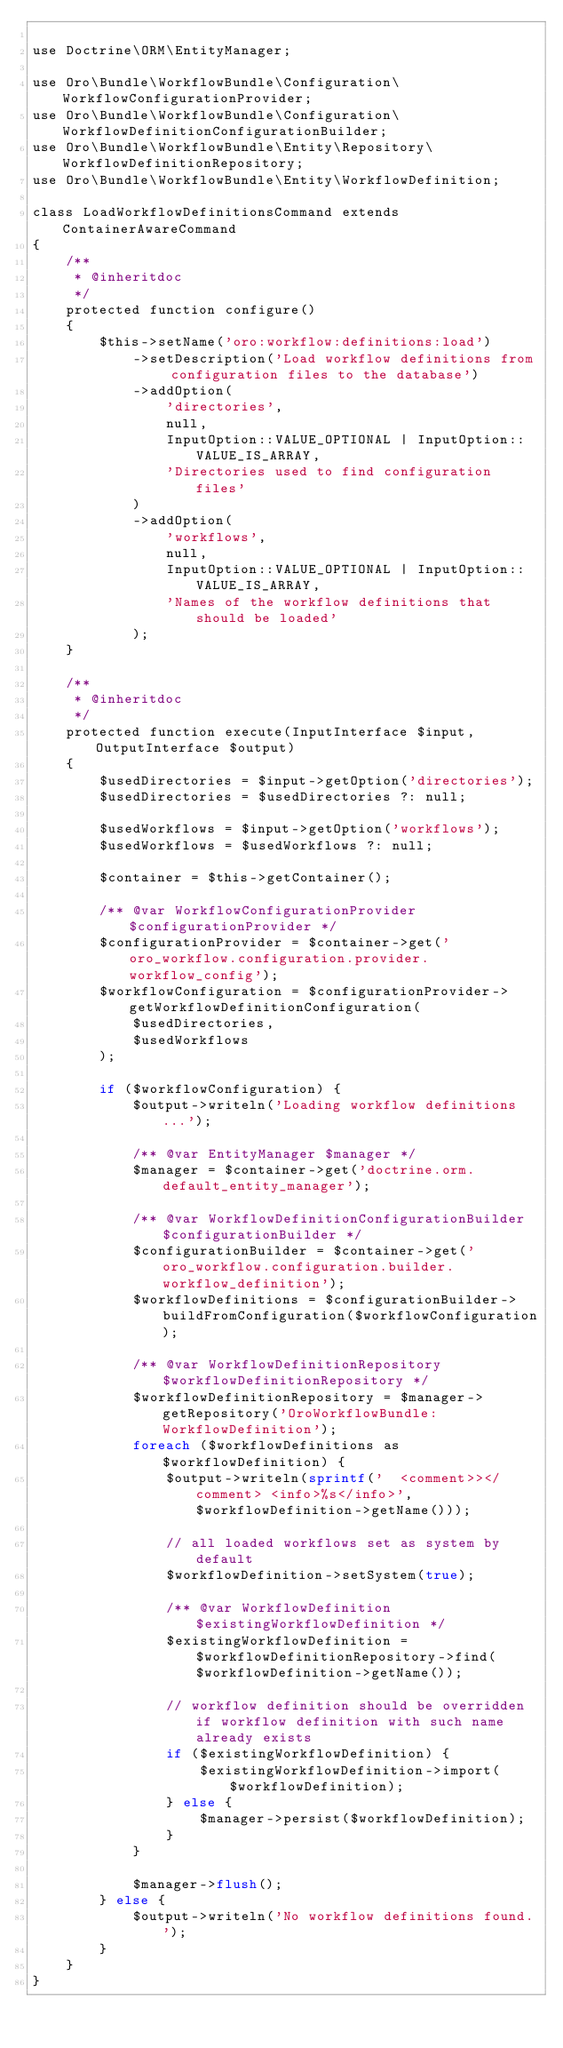Convert code to text. <code><loc_0><loc_0><loc_500><loc_500><_PHP_>
use Doctrine\ORM\EntityManager;

use Oro\Bundle\WorkflowBundle\Configuration\WorkflowConfigurationProvider;
use Oro\Bundle\WorkflowBundle\Configuration\WorkflowDefinitionConfigurationBuilder;
use Oro\Bundle\WorkflowBundle\Entity\Repository\WorkflowDefinitionRepository;
use Oro\Bundle\WorkflowBundle\Entity\WorkflowDefinition;

class LoadWorkflowDefinitionsCommand extends ContainerAwareCommand
{
    /**
     * @inheritdoc
     */
    protected function configure()
    {
        $this->setName('oro:workflow:definitions:load')
            ->setDescription('Load workflow definitions from configuration files to the database')
            ->addOption(
                'directories',
                null,
                InputOption::VALUE_OPTIONAL | InputOption::VALUE_IS_ARRAY,
                'Directories used to find configuration files'
            )
            ->addOption(
                'workflows',
                null,
                InputOption::VALUE_OPTIONAL | InputOption::VALUE_IS_ARRAY,
                'Names of the workflow definitions that should be loaded'
            );
    }

    /**
     * @inheritdoc
     */
    protected function execute(InputInterface $input, OutputInterface $output)
    {
        $usedDirectories = $input->getOption('directories');
        $usedDirectories = $usedDirectories ?: null;

        $usedWorkflows = $input->getOption('workflows');
        $usedWorkflows = $usedWorkflows ?: null;

        $container = $this->getContainer();

        /** @var WorkflowConfigurationProvider $configurationProvider */
        $configurationProvider = $container->get('oro_workflow.configuration.provider.workflow_config');
        $workflowConfiguration = $configurationProvider->getWorkflowDefinitionConfiguration(
            $usedDirectories,
            $usedWorkflows
        );

        if ($workflowConfiguration) {
            $output->writeln('Loading workflow definitions...');

            /** @var EntityManager $manager */
            $manager = $container->get('doctrine.orm.default_entity_manager');

            /** @var WorkflowDefinitionConfigurationBuilder $configurationBuilder */
            $configurationBuilder = $container->get('oro_workflow.configuration.builder.workflow_definition');
            $workflowDefinitions = $configurationBuilder->buildFromConfiguration($workflowConfiguration);

            /** @var WorkflowDefinitionRepository $workflowDefinitionRepository */
            $workflowDefinitionRepository = $manager->getRepository('OroWorkflowBundle:WorkflowDefinition');
            foreach ($workflowDefinitions as $workflowDefinition) {
                $output->writeln(sprintf('  <comment>></comment> <info>%s</info>', $workflowDefinition->getName()));

                // all loaded workflows set as system by default
                $workflowDefinition->setSystem(true);

                /** @var WorkflowDefinition $existingWorkflowDefinition */
                $existingWorkflowDefinition = $workflowDefinitionRepository->find($workflowDefinition->getName());

                // workflow definition should be overridden if workflow definition with such name already exists
                if ($existingWorkflowDefinition) {
                    $existingWorkflowDefinition->import($workflowDefinition);
                } else {
                    $manager->persist($workflowDefinition);
                }
            }

            $manager->flush();
        } else {
            $output->writeln('No workflow definitions found.');
        }
    }
}
</code> 